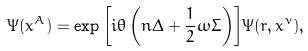Convert formula to latex. <formula><loc_0><loc_0><loc_500><loc_500>\Psi ( x ^ { A } ) = \exp { \left [ i \theta \left ( n \Delta + \frac { 1 } { 2 } \omega \Sigma \right ) \right ] } \Psi ( r , x ^ { \nu } ) ,</formula> 